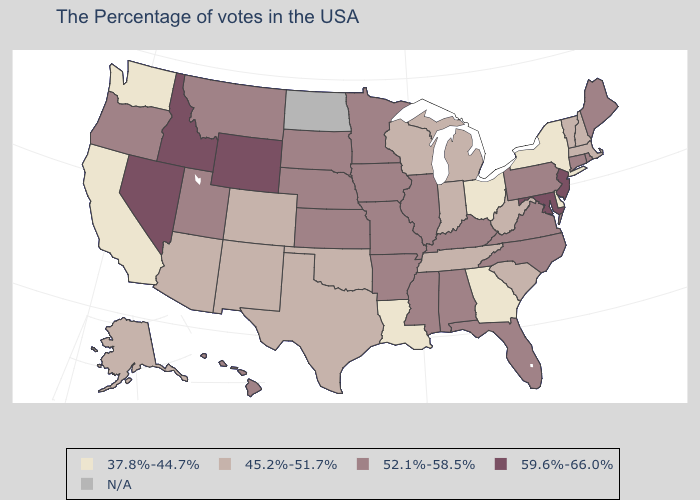Among the states that border Michigan , does Wisconsin have the lowest value?
Keep it brief. No. What is the value of California?
Concise answer only. 37.8%-44.7%. What is the highest value in states that border Oregon?
Keep it brief. 59.6%-66.0%. What is the value of Missouri?
Keep it brief. 52.1%-58.5%. Does Louisiana have the lowest value in the South?
Answer briefly. Yes. What is the value of Utah?
Give a very brief answer. 52.1%-58.5%. What is the value of Missouri?
Keep it brief. 52.1%-58.5%. What is the value of Nebraska?
Answer briefly. 52.1%-58.5%. Which states have the lowest value in the USA?
Concise answer only. New York, Delaware, Ohio, Georgia, Louisiana, California, Washington. Among the states that border New Jersey , which have the highest value?
Short answer required. Pennsylvania. What is the value of Montana?
Give a very brief answer. 52.1%-58.5%. Name the states that have a value in the range 37.8%-44.7%?
Write a very short answer. New York, Delaware, Ohio, Georgia, Louisiana, California, Washington. Among the states that border Michigan , which have the highest value?
Quick response, please. Indiana, Wisconsin. What is the value of Arkansas?
Write a very short answer. 52.1%-58.5%. 